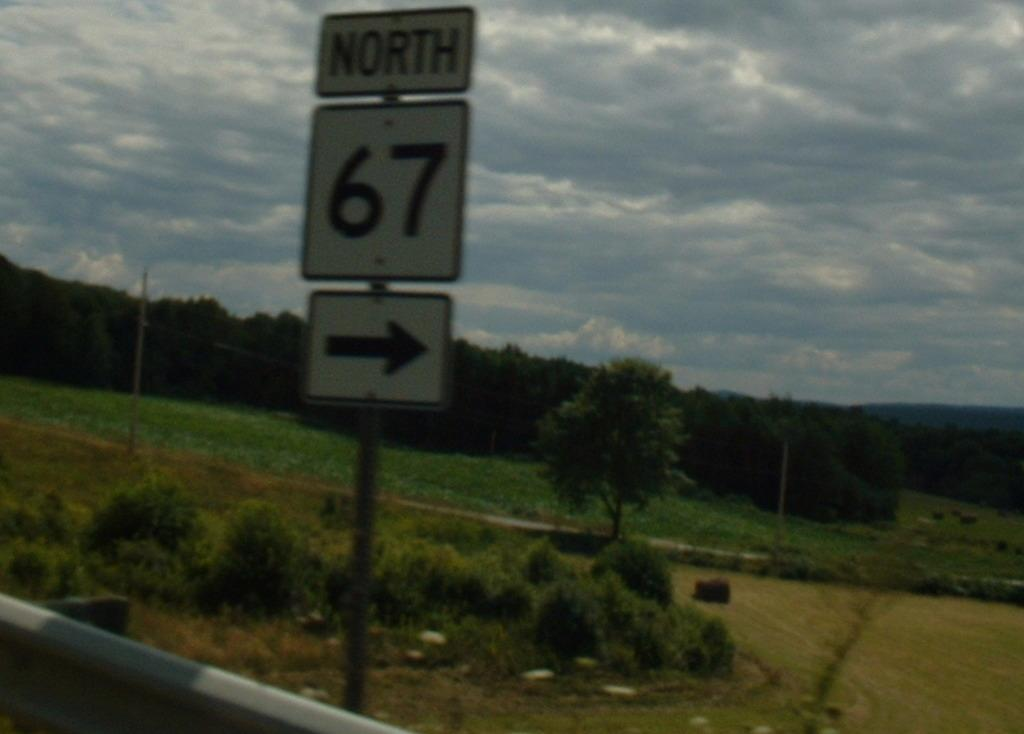<image>
Present a compact description of the photo's key features. the number 67 that is on a pole 